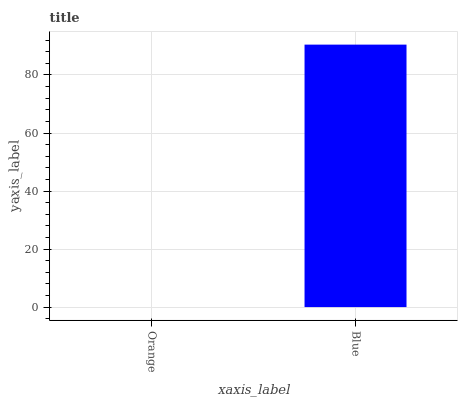Is Orange the minimum?
Answer yes or no. Yes. Is Blue the maximum?
Answer yes or no. Yes. Is Blue the minimum?
Answer yes or no. No. Is Blue greater than Orange?
Answer yes or no. Yes. Is Orange less than Blue?
Answer yes or no. Yes. Is Orange greater than Blue?
Answer yes or no. No. Is Blue less than Orange?
Answer yes or no. No. Is Blue the high median?
Answer yes or no. Yes. Is Orange the low median?
Answer yes or no. Yes. Is Orange the high median?
Answer yes or no. No. Is Blue the low median?
Answer yes or no. No. 